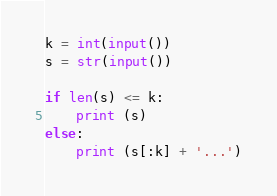<code> <loc_0><loc_0><loc_500><loc_500><_Python_>k = int(input())
s = str(input())

if len(s) <= k:
    print (s)
else:
    print (s[:k] + '...')
</code> 